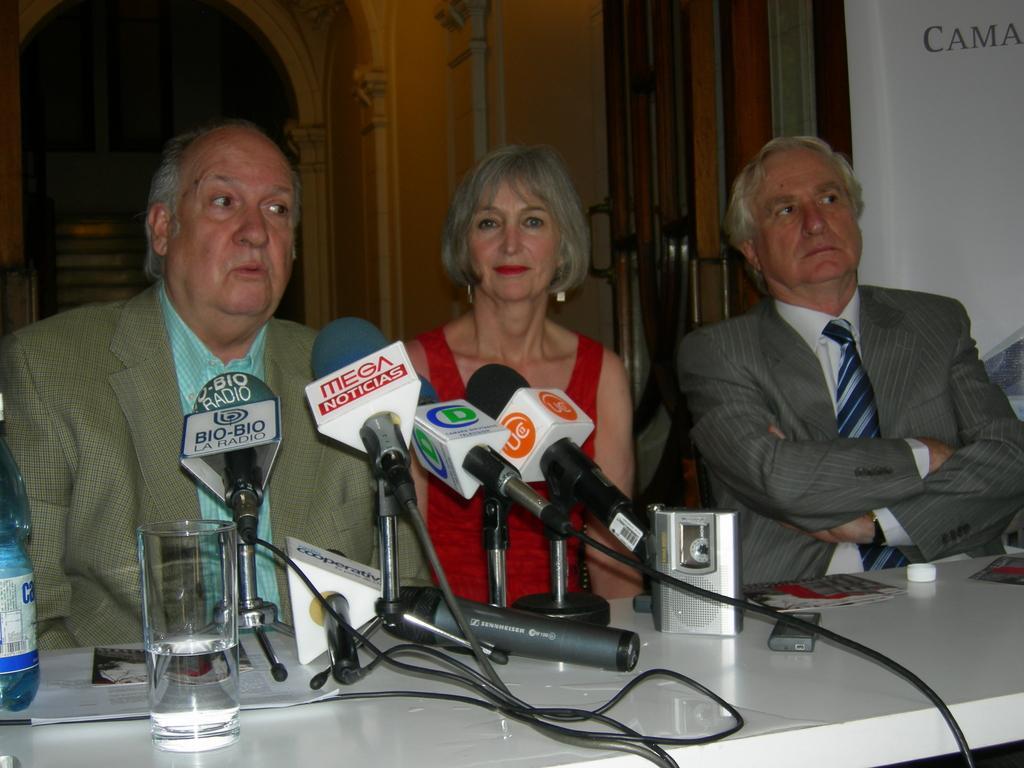How would you summarize this image in a sentence or two? Here we can see three persons are sitting on the chairs. This is table. On the table there are mike's, glass, bottle, and papers. In the background we can see a wall and a door. 